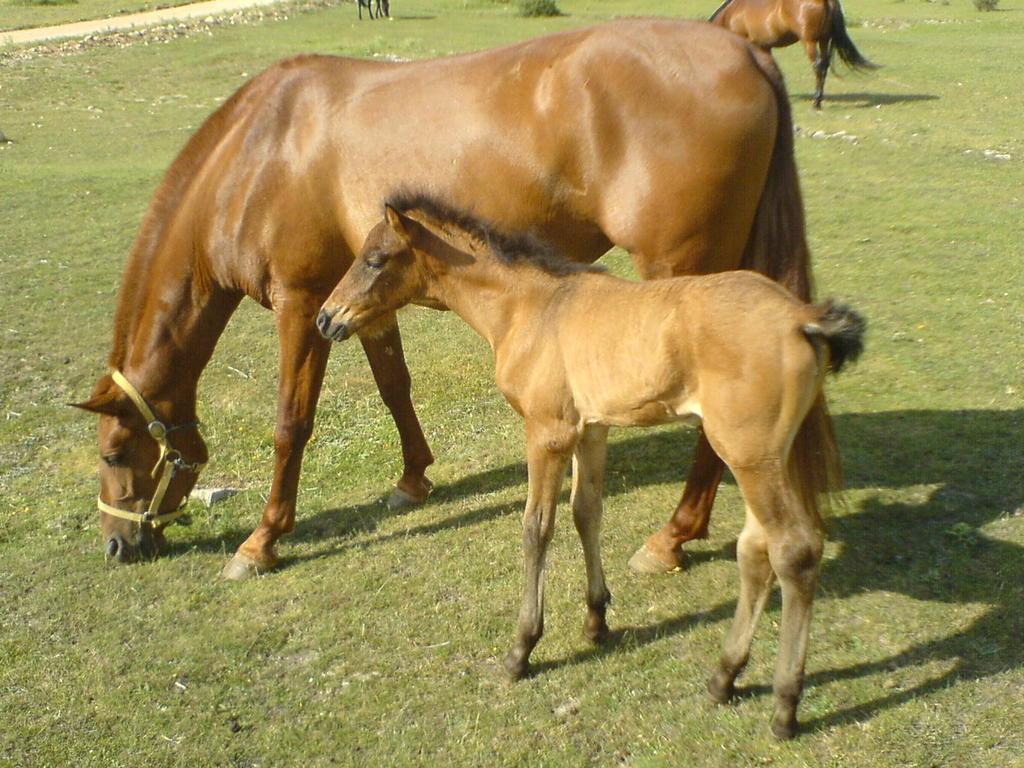Could you give a brief overview of what you see in this image? In this picture there is a horse and a pony in the center of the image on the grassland and there is another horse at the top side of the image. 